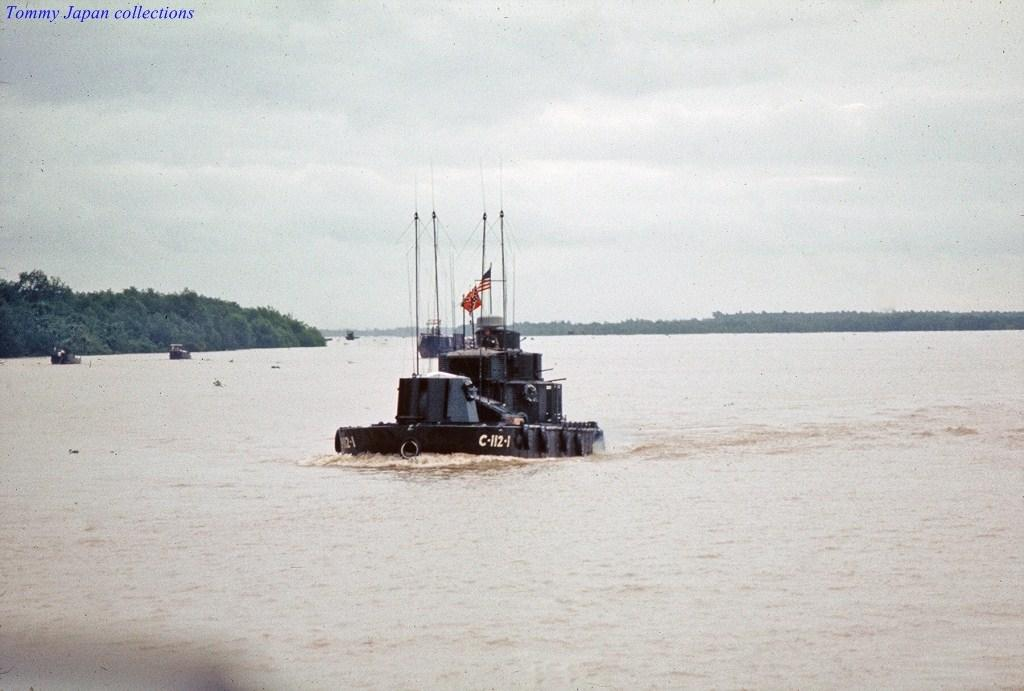What is in the water in the image? There are boats in the water in the image. What colors are present on the flags in the image? The flags in the image have blue, white, and red colors. What type of vegetation can be seen in the background of the image? There are trees in the background of the image, and they are green. What is the color of the sky in the image? The sky is white in color in the image. What type of joke is being told by the animals in the zoo in the image? There is no zoo or animals present in the image; it features boats in the water, flags, trees, and a white sky. Can you compare the size of the boats to the trees in the image? The provided facts do not include information about the size of the boats or trees, so it is not possible to make a comparison. 